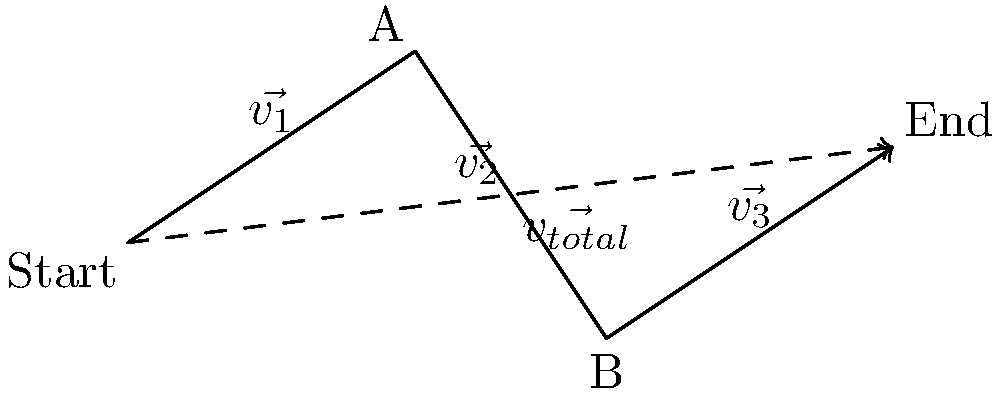During a crucial play, Cody Fajardo runs from the starting point to point A, then to point B, and finally to the end point as shown in the diagram. If $\vec{v_1} = 3\hat{i} + 2\hat{j}$, $\vec{v_2} = 2\hat{i} - 3\hat{j}$, and $\vec{v_3} = 3\hat{i} + 2\hat{j}$, what is the total displacement vector $\vec{v_{total}}$? To find the total displacement vector, we need to add all the individual displacement vectors:

$\vec{v_{total}} = \vec{v_1} + \vec{v_2} + \vec{v_3}$

Let's break it down step by step:

1) First, let's add the i-components:
   $3\hat{i} + 2\hat{i} + 3\hat{i} = 8\hat{i}$

2) Now, let's add the j-components:
   $2\hat{j} + (-3\hat{j}) + 2\hat{j} = \hat{j}$

3) Combining the results from steps 1 and 2:
   $\vec{v_{total}} = 8\hat{i} + \hat{j}$

This vector represents Cody Fajardo's total displacement from the starting point to the end point, regardless of the path he took to get there.
Answer: $8\hat{i} + \hat{j}$ 